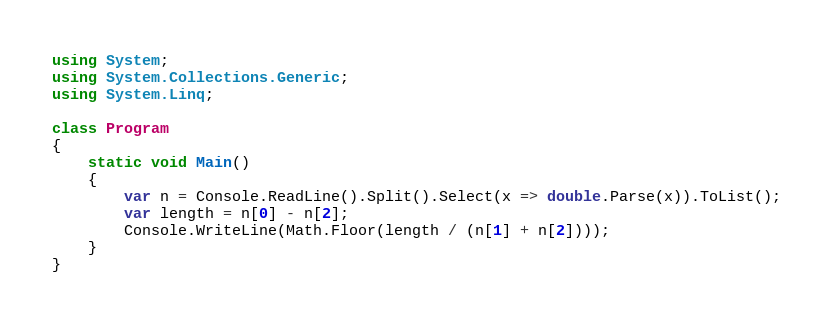Convert code to text. <code><loc_0><loc_0><loc_500><loc_500><_C#_>using System;
using System.Collections.Generic;
using System.Linq;

class Program
{
    static void Main()
    {
        var n = Console.ReadLine().Split().Select(x => double.Parse(x)).ToList();
        var length = n[0] - n[2];
        Console.WriteLine(Math.Floor(length / (n[1] + n[2])));
    }
}

</code> 